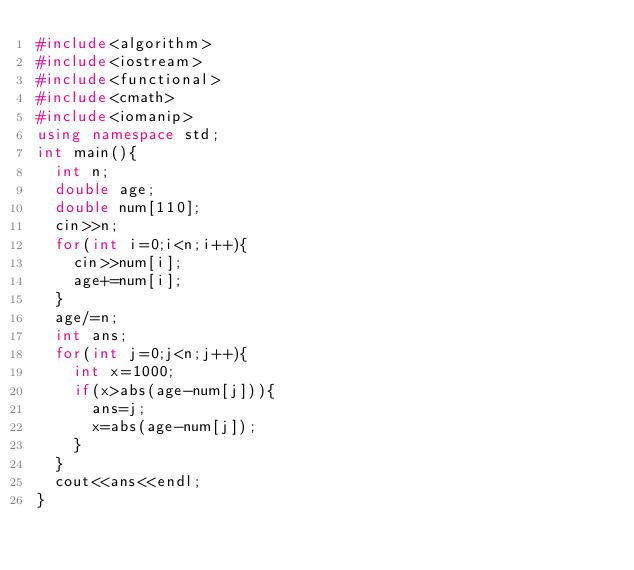<code> <loc_0><loc_0><loc_500><loc_500><_C++_>#include<algorithm>
#include<iostream>
#include<functional>
#include<cmath>
#include<iomanip>
using namespace std;
int main(){
  int n;
  double age;
  double num[110];
  cin>>n;
  for(int i=0;i<n;i++){
    cin>>num[i];
    age+=num[i];
  }
  age/=n;
  int ans;
  for(int j=0;j<n;j++){
    int x=1000;
    if(x>abs(age-num[j])){
      ans=j;
      x=abs(age-num[j]);
    }
  }
  cout<<ans<<endl;
}</code> 